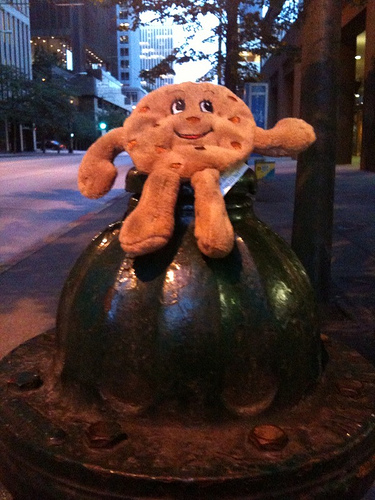<image>
Can you confirm if the cookie is on the fire hydrant? Yes. Looking at the image, I can see the cookie is positioned on top of the fire hydrant, with the fire hydrant providing support. 